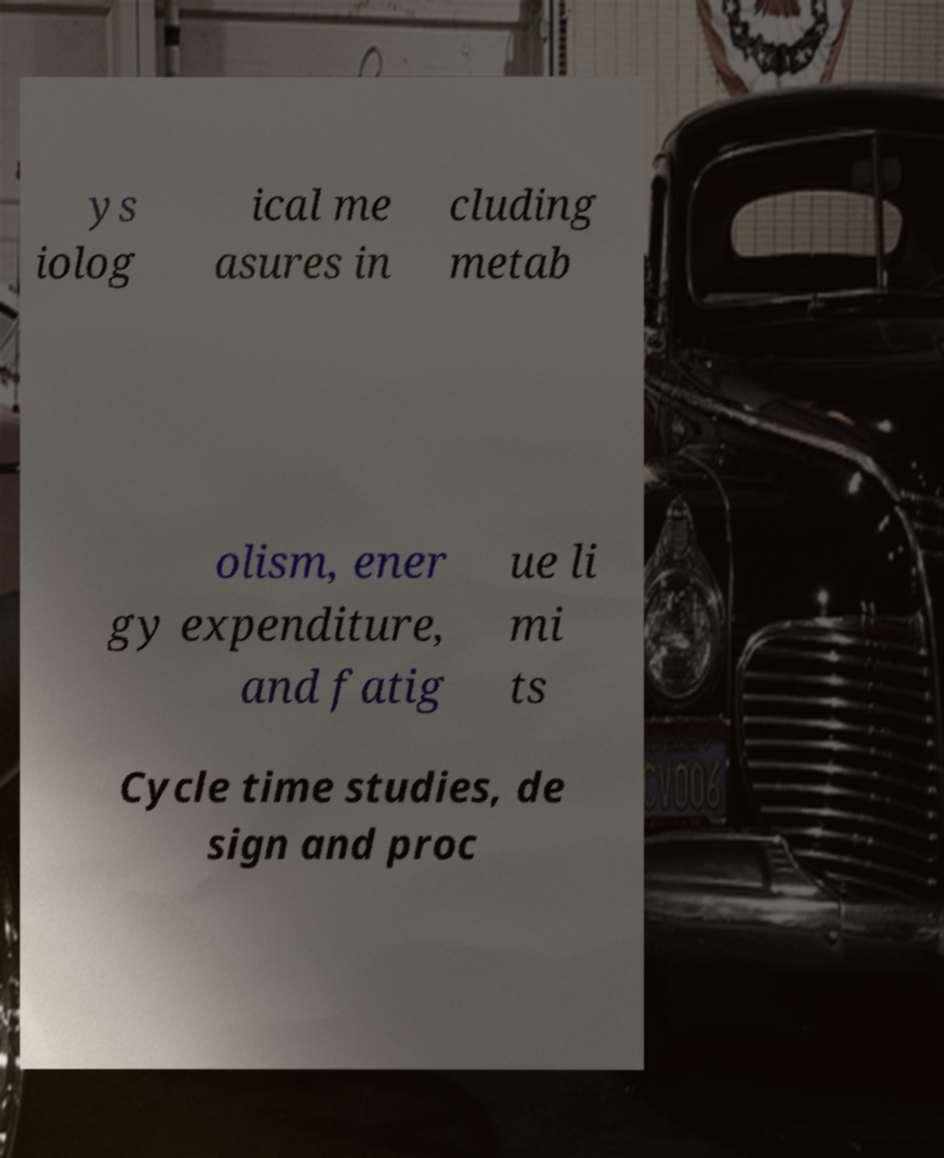What messages or text are displayed in this image? I need them in a readable, typed format. ys iolog ical me asures in cluding metab olism, ener gy expenditure, and fatig ue li mi ts Cycle time studies, de sign and proc 